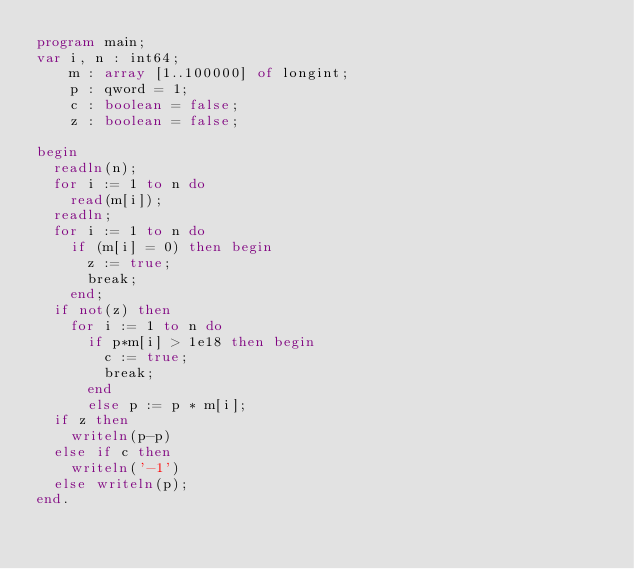<code> <loc_0><loc_0><loc_500><loc_500><_Pascal_>program main;
var i, n : int64;
    m : array [1..100000] of longint;
    p : qword = 1;
    c : boolean = false;
    z : boolean = false;
 
begin
  readln(n);
  for i := 1 to n do
    read(m[i]);
  readln;
  for i := 1 to n do
    if (m[i] = 0) then begin
      z := true;
      break;
    end;
  if not(z) then
    for i := 1 to n do
      if p*m[i] > 1e18 then begin
        c := true;
        break;
      end
      else p := p * m[i];
  if z then
    writeln(p-p)
  else if c then
    writeln('-1')
  else writeln(p);
end.</code> 